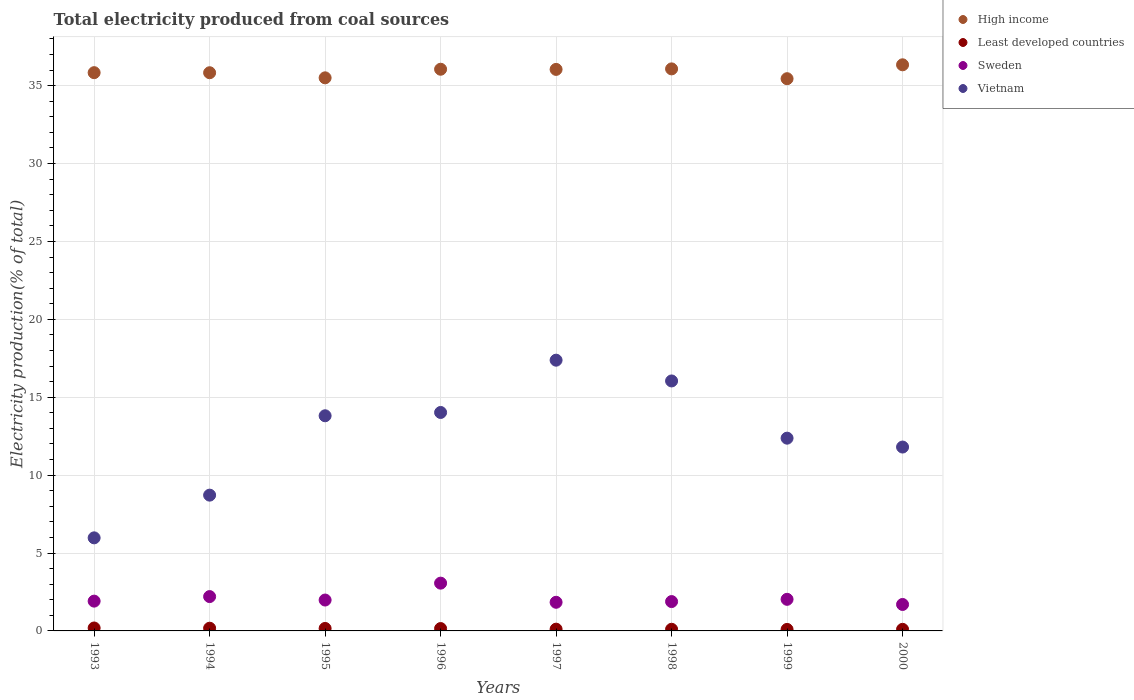What is the total electricity produced in Least developed countries in 1999?
Your answer should be compact. 0.1. Across all years, what is the maximum total electricity produced in Sweden?
Your answer should be very brief. 3.07. Across all years, what is the minimum total electricity produced in Least developed countries?
Offer a terse response. 0.1. In which year was the total electricity produced in Sweden maximum?
Make the answer very short. 1996. What is the total total electricity produced in Sweden in the graph?
Provide a short and direct response. 16.61. What is the difference between the total electricity produced in Sweden in 1995 and that in 1996?
Your answer should be compact. -1.08. What is the difference between the total electricity produced in Sweden in 2000 and the total electricity produced in Least developed countries in 1996?
Keep it short and to the point. 1.55. What is the average total electricity produced in Sweden per year?
Provide a succinct answer. 2.08. In the year 1997, what is the difference between the total electricity produced in Vietnam and total electricity produced in High income?
Make the answer very short. -18.67. What is the ratio of the total electricity produced in Vietnam in 1995 to that in 1999?
Your answer should be very brief. 1.12. Is the total electricity produced in Sweden in 1994 less than that in 1999?
Offer a terse response. No. What is the difference between the highest and the second highest total electricity produced in Vietnam?
Provide a succinct answer. 1.33. What is the difference between the highest and the lowest total electricity produced in Vietnam?
Offer a very short reply. 11.4. In how many years, is the total electricity produced in High income greater than the average total electricity produced in High income taken over all years?
Make the answer very short. 4. Does the total electricity produced in Vietnam monotonically increase over the years?
Provide a short and direct response. No. Is the total electricity produced in High income strictly greater than the total electricity produced in Least developed countries over the years?
Ensure brevity in your answer.  Yes. Is the total electricity produced in Vietnam strictly less than the total electricity produced in High income over the years?
Give a very brief answer. Yes. How many dotlines are there?
Your answer should be very brief. 4. Are the values on the major ticks of Y-axis written in scientific E-notation?
Provide a short and direct response. No. Where does the legend appear in the graph?
Provide a succinct answer. Top right. What is the title of the graph?
Provide a succinct answer. Total electricity produced from coal sources. What is the label or title of the Y-axis?
Offer a terse response. Electricity production(% of total). What is the Electricity production(% of total) in High income in 1993?
Make the answer very short. 35.83. What is the Electricity production(% of total) of Least developed countries in 1993?
Provide a short and direct response. 0.19. What is the Electricity production(% of total) of Sweden in 1993?
Ensure brevity in your answer.  1.91. What is the Electricity production(% of total) in Vietnam in 1993?
Ensure brevity in your answer.  5.97. What is the Electricity production(% of total) in High income in 1994?
Provide a short and direct response. 35.83. What is the Electricity production(% of total) of Least developed countries in 1994?
Ensure brevity in your answer.  0.17. What is the Electricity production(% of total) in Sweden in 1994?
Keep it short and to the point. 2.2. What is the Electricity production(% of total) of Vietnam in 1994?
Provide a succinct answer. 8.72. What is the Electricity production(% of total) of High income in 1995?
Keep it short and to the point. 35.5. What is the Electricity production(% of total) of Least developed countries in 1995?
Keep it short and to the point. 0.16. What is the Electricity production(% of total) of Sweden in 1995?
Provide a short and direct response. 1.98. What is the Electricity production(% of total) of Vietnam in 1995?
Give a very brief answer. 13.81. What is the Electricity production(% of total) of High income in 1996?
Keep it short and to the point. 36.05. What is the Electricity production(% of total) in Least developed countries in 1996?
Keep it short and to the point. 0.15. What is the Electricity production(% of total) in Sweden in 1996?
Ensure brevity in your answer.  3.07. What is the Electricity production(% of total) of Vietnam in 1996?
Offer a very short reply. 14.02. What is the Electricity production(% of total) of High income in 1997?
Make the answer very short. 36.04. What is the Electricity production(% of total) of Least developed countries in 1997?
Offer a terse response. 0.11. What is the Electricity production(% of total) of Sweden in 1997?
Your response must be concise. 1.84. What is the Electricity production(% of total) of Vietnam in 1997?
Keep it short and to the point. 17.38. What is the Electricity production(% of total) of High income in 1998?
Give a very brief answer. 36.08. What is the Electricity production(% of total) of Least developed countries in 1998?
Your response must be concise. 0.11. What is the Electricity production(% of total) in Sweden in 1998?
Offer a very short reply. 1.88. What is the Electricity production(% of total) of Vietnam in 1998?
Ensure brevity in your answer.  16.05. What is the Electricity production(% of total) in High income in 1999?
Give a very brief answer. 35.45. What is the Electricity production(% of total) in Least developed countries in 1999?
Offer a terse response. 0.1. What is the Electricity production(% of total) in Sweden in 1999?
Offer a terse response. 2.03. What is the Electricity production(% of total) of Vietnam in 1999?
Offer a very short reply. 12.37. What is the Electricity production(% of total) in High income in 2000?
Make the answer very short. 36.34. What is the Electricity production(% of total) in Least developed countries in 2000?
Your answer should be compact. 0.1. What is the Electricity production(% of total) of Sweden in 2000?
Offer a terse response. 1.7. What is the Electricity production(% of total) of Vietnam in 2000?
Ensure brevity in your answer.  11.8. Across all years, what is the maximum Electricity production(% of total) of High income?
Provide a short and direct response. 36.34. Across all years, what is the maximum Electricity production(% of total) of Least developed countries?
Keep it short and to the point. 0.19. Across all years, what is the maximum Electricity production(% of total) of Sweden?
Give a very brief answer. 3.07. Across all years, what is the maximum Electricity production(% of total) in Vietnam?
Keep it short and to the point. 17.38. Across all years, what is the minimum Electricity production(% of total) of High income?
Make the answer very short. 35.45. Across all years, what is the minimum Electricity production(% of total) in Least developed countries?
Make the answer very short. 0.1. Across all years, what is the minimum Electricity production(% of total) in Sweden?
Ensure brevity in your answer.  1.7. Across all years, what is the minimum Electricity production(% of total) of Vietnam?
Your answer should be very brief. 5.97. What is the total Electricity production(% of total) in High income in the graph?
Offer a terse response. 287.13. What is the total Electricity production(% of total) of Least developed countries in the graph?
Provide a succinct answer. 1.09. What is the total Electricity production(% of total) of Sweden in the graph?
Offer a very short reply. 16.61. What is the total Electricity production(% of total) of Vietnam in the graph?
Keep it short and to the point. 100.12. What is the difference between the Electricity production(% of total) of High income in 1993 and that in 1994?
Offer a terse response. 0. What is the difference between the Electricity production(% of total) of Least developed countries in 1993 and that in 1994?
Your answer should be compact. 0.01. What is the difference between the Electricity production(% of total) in Sweden in 1993 and that in 1994?
Ensure brevity in your answer.  -0.29. What is the difference between the Electricity production(% of total) of Vietnam in 1993 and that in 1994?
Provide a succinct answer. -2.74. What is the difference between the Electricity production(% of total) in High income in 1993 and that in 1995?
Your answer should be very brief. 0.33. What is the difference between the Electricity production(% of total) in Least developed countries in 1993 and that in 1995?
Your answer should be very brief. 0.03. What is the difference between the Electricity production(% of total) in Sweden in 1993 and that in 1995?
Give a very brief answer. -0.07. What is the difference between the Electricity production(% of total) in Vietnam in 1993 and that in 1995?
Offer a very short reply. -7.84. What is the difference between the Electricity production(% of total) of High income in 1993 and that in 1996?
Keep it short and to the point. -0.22. What is the difference between the Electricity production(% of total) of Least developed countries in 1993 and that in 1996?
Keep it short and to the point. 0.04. What is the difference between the Electricity production(% of total) of Sweden in 1993 and that in 1996?
Offer a very short reply. -1.15. What is the difference between the Electricity production(% of total) of Vietnam in 1993 and that in 1996?
Give a very brief answer. -8.05. What is the difference between the Electricity production(% of total) in High income in 1993 and that in 1997?
Provide a succinct answer. -0.21. What is the difference between the Electricity production(% of total) of Least developed countries in 1993 and that in 1997?
Offer a very short reply. 0.08. What is the difference between the Electricity production(% of total) of Sweden in 1993 and that in 1997?
Keep it short and to the point. 0.07. What is the difference between the Electricity production(% of total) of Vietnam in 1993 and that in 1997?
Your answer should be very brief. -11.4. What is the difference between the Electricity production(% of total) in High income in 1993 and that in 1998?
Your response must be concise. -0.24. What is the difference between the Electricity production(% of total) in Least developed countries in 1993 and that in 1998?
Offer a very short reply. 0.08. What is the difference between the Electricity production(% of total) in Sweden in 1993 and that in 1998?
Ensure brevity in your answer.  0.03. What is the difference between the Electricity production(% of total) in Vietnam in 1993 and that in 1998?
Give a very brief answer. -10.07. What is the difference between the Electricity production(% of total) in High income in 1993 and that in 1999?
Offer a very short reply. 0.39. What is the difference between the Electricity production(% of total) of Least developed countries in 1993 and that in 1999?
Provide a succinct answer. 0.09. What is the difference between the Electricity production(% of total) of Sweden in 1993 and that in 1999?
Offer a terse response. -0.12. What is the difference between the Electricity production(% of total) of Vietnam in 1993 and that in 1999?
Keep it short and to the point. -6.4. What is the difference between the Electricity production(% of total) of High income in 1993 and that in 2000?
Ensure brevity in your answer.  -0.5. What is the difference between the Electricity production(% of total) of Least developed countries in 1993 and that in 2000?
Ensure brevity in your answer.  0.09. What is the difference between the Electricity production(% of total) in Sweden in 1993 and that in 2000?
Offer a terse response. 0.21. What is the difference between the Electricity production(% of total) in Vietnam in 1993 and that in 2000?
Your response must be concise. -5.83. What is the difference between the Electricity production(% of total) of High income in 1994 and that in 1995?
Offer a very short reply. 0.33. What is the difference between the Electricity production(% of total) of Least developed countries in 1994 and that in 1995?
Give a very brief answer. 0.02. What is the difference between the Electricity production(% of total) in Sweden in 1994 and that in 1995?
Your answer should be compact. 0.22. What is the difference between the Electricity production(% of total) in Vietnam in 1994 and that in 1995?
Your response must be concise. -5.09. What is the difference between the Electricity production(% of total) of High income in 1994 and that in 1996?
Offer a terse response. -0.22. What is the difference between the Electricity production(% of total) in Least developed countries in 1994 and that in 1996?
Your response must be concise. 0.02. What is the difference between the Electricity production(% of total) in Sweden in 1994 and that in 1996?
Make the answer very short. -0.86. What is the difference between the Electricity production(% of total) of Vietnam in 1994 and that in 1996?
Provide a succinct answer. -5.31. What is the difference between the Electricity production(% of total) of High income in 1994 and that in 1997?
Ensure brevity in your answer.  -0.21. What is the difference between the Electricity production(% of total) of Least developed countries in 1994 and that in 1997?
Offer a terse response. 0.06. What is the difference between the Electricity production(% of total) of Sweden in 1994 and that in 1997?
Provide a short and direct response. 0.37. What is the difference between the Electricity production(% of total) in Vietnam in 1994 and that in 1997?
Your answer should be very brief. -8.66. What is the difference between the Electricity production(% of total) of High income in 1994 and that in 1998?
Make the answer very short. -0.25. What is the difference between the Electricity production(% of total) in Least developed countries in 1994 and that in 1998?
Give a very brief answer. 0.07. What is the difference between the Electricity production(% of total) in Sweden in 1994 and that in 1998?
Make the answer very short. 0.32. What is the difference between the Electricity production(% of total) in Vietnam in 1994 and that in 1998?
Make the answer very short. -7.33. What is the difference between the Electricity production(% of total) of High income in 1994 and that in 1999?
Your answer should be compact. 0.38. What is the difference between the Electricity production(% of total) of Least developed countries in 1994 and that in 1999?
Ensure brevity in your answer.  0.08. What is the difference between the Electricity production(% of total) of Sweden in 1994 and that in 1999?
Your response must be concise. 0.18. What is the difference between the Electricity production(% of total) of Vietnam in 1994 and that in 1999?
Keep it short and to the point. -3.66. What is the difference between the Electricity production(% of total) in High income in 1994 and that in 2000?
Provide a succinct answer. -0.51. What is the difference between the Electricity production(% of total) of Least developed countries in 1994 and that in 2000?
Keep it short and to the point. 0.07. What is the difference between the Electricity production(% of total) in Sweden in 1994 and that in 2000?
Provide a short and direct response. 0.51. What is the difference between the Electricity production(% of total) in Vietnam in 1994 and that in 2000?
Offer a very short reply. -3.09. What is the difference between the Electricity production(% of total) in High income in 1995 and that in 1996?
Your response must be concise. -0.55. What is the difference between the Electricity production(% of total) in Least developed countries in 1995 and that in 1996?
Ensure brevity in your answer.  0.01. What is the difference between the Electricity production(% of total) of Sweden in 1995 and that in 1996?
Your answer should be compact. -1.08. What is the difference between the Electricity production(% of total) of Vietnam in 1995 and that in 1996?
Your answer should be compact. -0.21. What is the difference between the Electricity production(% of total) in High income in 1995 and that in 1997?
Your answer should be very brief. -0.54. What is the difference between the Electricity production(% of total) in Least developed countries in 1995 and that in 1997?
Offer a terse response. 0.05. What is the difference between the Electricity production(% of total) of Sweden in 1995 and that in 1997?
Your answer should be very brief. 0.14. What is the difference between the Electricity production(% of total) of Vietnam in 1995 and that in 1997?
Give a very brief answer. -3.57. What is the difference between the Electricity production(% of total) in High income in 1995 and that in 1998?
Ensure brevity in your answer.  -0.57. What is the difference between the Electricity production(% of total) in Least developed countries in 1995 and that in 1998?
Provide a succinct answer. 0.05. What is the difference between the Electricity production(% of total) in Sweden in 1995 and that in 1998?
Provide a short and direct response. 0.1. What is the difference between the Electricity production(% of total) in Vietnam in 1995 and that in 1998?
Your answer should be compact. -2.23. What is the difference between the Electricity production(% of total) in High income in 1995 and that in 1999?
Your response must be concise. 0.06. What is the difference between the Electricity production(% of total) in Least developed countries in 1995 and that in 1999?
Offer a terse response. 0.06. What is the difference between the Electricity production(% of total) in Sweden in 1995 and that in 1999?
Provide a short and direct response. -0.05. What is the difference between the Electricity production(% of total) in Vietnam in 1995 and that in 1999?
Your answer should be very brief. 1.44. What is the difference between the Electricity production(% of total) in High income in 1995 and that in 2000?
Your response must be concise. -0.84. What is the difference between the Electricity production(% of total) in Least developed countries in 1995 and that in 2000?
Provide a short and direct response. 0.06. What is the difference between the Electricity production(% of total) of Sweden in 1995 and that in 2000?
Give a very brief answer. 0.28. What is the difference between the Electricity production(% of total) of Vietnam in 1995 and that in 2000?
Provide a succinct answer. 2.01. What is the difference between the Electricity production(% of total) of High income in 1996 and that in 1997?
Provide a short and direct response. 0.01. What is the difference between the Electricity production(% of total) in Least developed countries in 1996 and that in 1997?
Your answer should be compact. 0.04. What is the difference between the Electricity production(% of total) in Sweden in 1996 and that in 1997?
Give a very brief answer. 1.23. What is the difference between the Electricity production(% of total) in Vietnam in 1996 and that in 1997?
Your answer should be very brief. -3.36. What is the difference between the Electricity production(% of total) in High income in 1996 and that in 1998?
Your response must be concise. -0.02. What is the difference between the Electricity production(% of total) of Least developed countries in 1996 and that in 1998?
Offer a very short reply. 0.05. What is the difference between the Electricity production(% of total) in Sweden in 1996 and that in 1998?
Provide a succinct answer. 1.18. What is the difference between the Electricity production(% of total) in Vietnam in 1996 and that in 1998?
Provide a succinct answer. -2.02. What is the difference between the Electricity production(% of total) in High income in 1996 and that in 1999?
Your answer should be very brief. 0.61. What is the difference between the Electricity production(% of total) in Least developed countries in 1996 and that in 1999?
Keep it short and to the point. 0.06. What is the difference between the Electricity production(% of total) in Sweden in 1996 and that in 1999?
Keep it short and to the point. 1.04. What is the difference between the Electricity production(% of total) of Vietnam in 1996 and that in 1999?
Provide a short and direct response. 1.65. What is the difference between the Electricity production(% of total) in High income in 1996 and that in 2000?
Keep it short and to the point. -0.28. What is the difference between the Electricity production(% of total) of Least developed countries in 1996 and that in 2000?
Provide a succinct answer. 0.05. What is the difference between the Electricity production(% of total) of Sweden in 1996 and that in 2000?
Your answer should be compact. 1.37. What is the difference between the Electricity production(% of total) in Vietnam in 1996 and that in 2000?
Provide a short and direct response. 2.22. What is the difference between the Electricity production(% of total) of High income in 1997 and that in 1998?
Give a very brief answer. -0.03. What is the difference between the Electricity production(% of total) in Least developed countries in 1997 and that in 1998?
Make the answer very short. 0.01. What is the difference between the Electricity production(% of total) in Sweden in 1997 and that in 1998?
Provide a short and direct response. -0.05. What is the difference between the Electricity production(% of total) of Vietnam in 1997 and that in 1998?
Provide a succinct answer. 1.33. What is the difference between the Electricity production(% of total) in High income in 1997 and that in 1999?
Give a very brief answer. 0.6. What is the difference between the Electricity production(% of total) in Least developed countries in 1997 and that in 1999?
Keep it short and to the point. 0.02. What is the difference between the Electricity production(% of total) in Sweden in 1997 and that in 1999?
Offer a terse response. -0.19. What is the difference between the Electricity production(% of total) in Vietnam in 1997 and that in 1999?
Provide a short and direct response. 5.01. What is the difference between the Electricity production(% of total) of High income in 1997 and that in 2000?
Your answer should be very brief. -0.29. What is the difference between the Electricity production(% of total) of Least developed countries in 1997 and that in 2000?
Your answer should be compact. 0.01. What is the difference between the Electricity production(% of total) in Sweden in 1997 and that in 2000?
Keep it short and to the point. 0.14. What is the difference between the Electricity production(% of total) of Vietnam in 1997 and that in 2000?
Offer a terse response. 5.58. What is the difference between the Electricity production(% of total) in High income in 1998 and that in 1999?
Ensure brevity in your answer.  0.63. What is the difference between the Electricity production(% of total) in Least developed countries in 1998 and that in 1999?
Offer a terse response. 0.01. What is the difference between the Electricity production(% of total) of Sweden in 1998 and that in 1999?
Offer a terse response. -0.14. What is the difference between the Electricity production(% of total) in Vietnam in 1998 and that in 1999?
Ensure brevity in your answer.  3.67. What is the difference between the Electricity production(% of total) of High income in 1998 and that in 2000?
Keep it short and to the point. -0.26. What is the difference between the Electricity production(% of total) of Least developed countries in 1998 and that in 2000?
Your answer should be compact. 0. What is the difference between the Electricity production(% of total) in Sweden in 1998 and that in 2000?
Give a very brief answer. 0.19. What is the difference between the Electricity production(% of total) in Vietnam in 1998 and that in 2000?
Provide a succinct answer. 4.24. What is the difference between the Electricity production(% of total) of High income in 1999 and that in 2000?
Offer a terse response. -0.89. What is the difference between the Electricity production(% of total) of Least developed countries in 1999 and that in 2000?
Offer a terse response. -0.01. What is the difference between the Electricity production(% of total) of Sweden in 1999 and that in 2000?
Ensure brevity in your answer.  0.33. What is the difference between the Electricity production(% of total) of Vietnam in 1999 and that in 2000?
Offer a terse response. 0.57. What is the difference between the Electricity production(% of total) of High income in 1993 and the Electricity production(% of total) of Least developed countries in 1994?
Provide a succinct answer. 35.66. What is the difference between the Electricity production(% of total) in High income in 1993 and the Electricity production(% of total) in Sweden in 1994?
Your response must be concise. 33.63. What is the difference between the Electricity production(% of total) in High income in 1993 and the Electricity production(% of total) in Vietnam in 1994?
Ensure brevity in your answer.  27.12. What is the difference between the Electricity production(% of total) in Least developed countries in 1993 and the Electricity production(% of total) in Sweden in 1994?
Keep it short and to the point. -2.02. What is the difference between the Electricity production(% of total) of Least developed countries in 1993 and the Electricity production(% of total) of Vietnam in 1994?
Make the answer very short. -8.53. What is the difference between the Electricity production(% of total) of Sweden in 1993 and the Electricity production(% of total) of Vietnam in 1994?
Provide a succinct answer. -6.8. What is the difference between the Electricity production(% of total) of High income in 1993 and the Electricity production(% of total) of Least developed countries in 1995?
Make the answer very short. 35.68. What is the difference between the Electricity production(% of total) in High income in 1993 and the Electricity production(% of total) in Sweden in 1995?
Your answer should be very brief. 33.85. What is the difference between the Electricity production(% of total) in High income in 1993 and the Electricity production(% of total) in Vietnam in 1995?
Give a very brief answer. 22.02. What is the difference between the Electricity production(% of total) of Least developed countries in 1993 and the Electricity production(% of total) of Sweden in 1995?
Provide a short and direct response. -1.79. What is the difference between the Electricity production(% of total) of Least developed countries in 1993 and the Electricity production(% of total) of Vietnam in 1995?
Offer a very short reply. -13.62. What is the difference between the Electricity production(% of total) of Sweden in 1993 and the Electricity production(% of total) of Vietnam in 1995?
Your answer should be very brief. -11.9. What is the difference between the Electricity production(% of total) in High income in 1993 and the Electricity production(% of total) in Least developed countries in 1996?
Your answer should be very brief. 35.68. What is the difference between the Electricity production(% of total) in High income in 1993 and the Electricity production(% of total) in Sweden in 1996?
Your answer should be compact. 32.77. What is the difference between the Electricity production(% of total) in High income in 1993 and the Electricity production(% of total) in Vietnam in 1996?
Your response must be concise. 21.81. What is the difference between the Electricity production(% of total) of Least developed countries in 1993 and the Electricity production(% of total) of Sweden in 1996?
Your answer should be very brief. -2.88. What is the difference between the Electricity production(% of total) in Least developed countries in 1993 and the Electricity production(% of total) in Vietnam in 1996?
Provide a short and direct response. -13.83. What is the difference between the Electricity production(% of total) in Sweden in 1993 and the Electricity production(% of total) in Vietnam in 1996?
Keep it short and to the point. -12.11. What is the difference between the Electricity production(% of total) in High income in 1993 and the Electricity production(% of total) in Least developed countries in 1997?
Provide a succinct answer. 35.72. What is the difference between the Electricity production(% of total) in High income in 1993 and the Electricity production(% of total) in Sweden in 1997?
Your answer should be very brief. 34. What is the difference between the Electricity production(% of total) of High income in 1993 and the Electricity production(% of total) of Vietnam in 1997?
Your response must be concise. 18.46. What is the difference between the Electricity production(% of total) in Least developed countries in 1993 and the Electricity production(% of total) in Sweden in 1997?
Your answer should be compact. -1.65. What is the difference between the Electricity production(% of total) in Least developed countries in 1993 and the Electricity production(% of total) in Vietnam in 1997?
Provide a succinct answer. -17.19. What is the difference between the Electricity production(% of total) of Sweden in 1993 and the Electricity production(% of total) of Vietnam in 1997?
Make the answer very short. -15.47. What is the difference between the Electricity production(% of total) of High income in 1993 and the Electricity production(% of total) of Least developed countries in 1998?
Provide a succinct answer. 35.73. What is the difference between the Electricity production(% of total) in High income in 1993 and the Electricity production(% of total) in Sweden in 1998?
Keep it short and to the point. 33.95. What is the difference between the Electricity production(% of total) in High income in 1993 and the Electricity production(% of total) in Vietnam in 1998?
Offer a terse response. 19.79. What is the difference between the Electricity production(% of total) of Least developed countries in 1993 and the Electricity production(% of total) of Sweden in 1998?
Offer a very short reply. -1.7. What is the difference between the Electricity production(% of total) of Least developed countries in 1993 and the Electricity production(% of total) of Vietnam in 1998?
Your answer should be very brief. -15.86. What is the difference between the Electricity production(% of total) in Sweden in 1993 and the Electricity production(% of total) in Vietnam in 1998?
Provide a short and direct response. -14.13. What is the difference between the Electricity production(% of total) in High income in 1993 and the Electricity production(% of total) in Least developed countries in 1999?
Your response must be concise. 35.74. What is the difference between the Electricity production(% of total) in High income in 1993 and the Electricity production(% of total) in Sweden in 1999?
Offer a very short reply. 33.81. What is the difference between the Electricity production(% of total) in High income in 1993 and the Electricity production(% of total) in Vietnam in 1999?
Keep it short and to the point. 23.46. What is the difference between the Electricity production(% of total) in Least developed countries in 1993 and the Electricity production(% of total) in Sweden in 1999?
Ensure brevity in your answer.  -1.84. What is the difference between the Electricity production(% of total) of Least developed countries in 1993 and the Electricity production(% of total) of Vietnam in 1999?
Your answer should be very brief. -12.18. What is the difference between the Electricity production(% of total) of Sweden in 1993 and the Electricity production(% of total) of Vietnam in 1999?
Ensure brevity in your answer.  -10.46. What is the difference between the Electricity production(% of total) of High income in 1993 and the Electricity production(% of total) of Least developed countries in 2000?
Ensure brevity in your answer.  35.73. What is the difference between the Electricity production(% of total) in High income in 1993 and the Electricity production(% of total) in Sweden in 2000?
Your response must be concise. 34.14. What is the difference between the Electricity production(% of total) in High income in 1993 and the Electricity production(% of total) in Vietnam in 2000?
Provide a succinct answer. 24.03. What is the difference between the Electricity production(% of total) of Least developed countries in 1993 and the Electricity production(% of total) of Sweden in 2000?
Offer a terse response. -1.51. What is the difference between the Electricity production(% of total) of Least developed countries in 1993 and the Electricity production(% of total) of Vietnam in 2000?
Ensure brevity in your answer.  -11.61. What is the difference between the Electricity production(% of total) of Sweden in 1993 and the Electricity production(% of total) of Vietnam in 2000?
Keep it short and to the point. -9.89. What is the difference between the Electricity production(% of total) of High income in 1994 and the Electricity production(% of total) of Least developed countries in 1995?
Ensure brevity in your answer.  35.67. What is the difference between the Electricity production(% of total) in High income in 1994 and the Electricity production(% of total) in Sweden in 1995?
Offer a very short reply. 33.85. What is the difference between the Electricity production(% of total) in High income in 1994 and the Electricity production(% of total) in Vietnam in 1995?
Keep it short and to the point. 22.02. What is the difference between the Electricity production(% of total) of Least developed countries in 1994 and the Electricity production(% of total) of Sweden in 1995?
Your response must be concise. -1.81. What is the difference between the Electricity production(% of total) of Least developed countries in 1994 and the Electricity production(% of total) of Vietnam in 1995?
Provide a short and direct response. -13.64. What is the difference between the Electricity production(% of total) in Sweden in 1994 and the Electricity production(% of total) in Vietnam in 1995?
Your answer should be compact. -11.61. What is the difference between the Electricity production(% of total) in High income in 1994 and the Electricity production(% of total) in Least developed countries in 1996?
Ensure brevity in your answer.  35.68. What is the difference between the Electricity production(% of total) of High income in 1994 and the Electricity production(% of total) of Sweden in 1996?
Offer a terse response. 32.76. What is the difference between the Electricity production(% of total) of High income in 1994 and the Electricity production(% of total) of Vietnam in 1996?
Offer a very short reply. 21.81. What is the difference between the Electricity production(% of total) of Least developed countries in 1994 and the Electricity production(% of total) of Sweden in 1996?
Your answer should be very brief. -2.89. What is the difference between the Electricity production(% of total) of Least developed countries in 1994 and the Electricity production(% of total) of Vietnam in 1996?
Ensure brevity in your answer.  -13.85. What is the difference between the Electricity production(% of total) of Sweden in 1994 and the Electricity production(% of total) of Vietnam in 1996?
Keep it short and to the point. -11.82. What is the difference between the Electricity production(% of total) in High income in 1994 and the Electricity production(% of total) in Least developed countries in 1997?
Your response must be concise. 35.72. What is the difference between the Electricity production(% of total) of High income in 1994 and the Electricity production(% of total) of Sweden in 1997?
Give a very brief answer. 33.99. What is the difference between the Electricity production(% of total) in High income in 1994 and the Electricity production(% of total) in Vietnam in 1997?
Your response must be concise. 18.45. What is the difference between the Electricity production(% of total) of Least developed countries in 1994 and the Electricity production(% of total) of Sweden in 1997?
Give a very brief answer. -1.66. What is the difference between the Electricity production(% of total) in Least developed countries in 1994 and the Electricity production(% of total) in Vietnam in 1997?
Offer a very short reply. -17.2. What is the difference between the Electricity production(% of total) in Sweden in 1994 and the Electricity production(% of total) in Vietnam in 1997?
Your answer should be compact. -15.18. What is the difference between the Electricity production(% of total) in High income in 1994 and the Electricity production(% of total) in Least developed countries in 1998?
Provide a short and direct response. 35.72. What is the difference between the Electricity production(% of total) in High income in 1994 and the Electricity production(% of total) in Sweden in 1998?
Offer a very short reply. 33.95. What is the difference between the Electricity production(% of total) in High income in 1994 and the Electricity production(% of total) in Vietnam in 1998?
Ensure brevity in your answer.  19.78. What is the difference between the Electricity production(% of total) of Least developed countries in 1994 and the Electricity production(% of total) of Sweden in 1998?
Make the answer very short. -1.71. What is the difference between the Electricity production(% of total) of Least developed countries in 1994 and the Electricity production(% of total) of Vietnam in 1998?
Offer a terse response. -15.87. What is the difference between the Electricity production(% of total) in Sweden in 1994 and the Electricity production(% of total) in Vietnam in 1998?
Make the answer very short. -13.84. What is the difference between the Electricity production(% of total) of High income in 1994 and the Electricity production(% of total) of Least developed countries in 1999?
Provide a succinct answer. 35.73. What is the difference between the Electricity production(% of total) of High income in 1994 and the Electricity production(% of total) of Sweden in 1999?
Your answer should be very brief. 33.8. What is the difference between the Electricity production(% of total) in High income in 1994 and the Electricity production(% of total) in Vietnam in 1999?
Provide a short and direct response. 23.46. What is the difference between the Electricity production(% of total) in Least developed countries in 1994 and the Electricity production(% of total) in Sweden in 1999?
Make the answer very short. -1.85. What is the difference between the Electricity production(% of total) in Least developed countries in 1994 and the Electricity production(% of total) in Vietnam in 1999?
Keep it short and to the point. -12.2. What is the difference between the Electricity production(% of total) of Sweden in 1994 and the Electricity production(% of total) of Vietnam in 1999?
Provide a short and direct response. -10.17. What is the difference between the Electricity production(% of total) of High income in 1994 and the Electricity production(% of total) of Least developed countries in 2000?
Offer a terse response. 35.73. What is the difference between the Electricity production(% of total) of High income in 1994 and the Electricity production(% of total) of Sweden in 2000?
Provide a succinct answer. 34.13. What is the difference between the Electricity production(% of total) of High income in 1994 and the Electricity production(% of total) of Vietnam in 2000?
Your answer should be compact. 24.03. What is the difference between the Electricity production(% of total) in Least developed countries in 1994 and the Electricity production(% of total) in Sweden in 2000?
Offer a terse response. -1.52. What is the difference between the Electricity production(% of total) of Least developed countries in 1994 and the Electricity production(% of total) of Vietnam in 2000?
Provide a succinct answer. -11.63. What is the difference between the Electricity production(% of total) of Sweden in 1994 and the Electricity production(% of total) of Vietnam in 2000?
Make the answer very short. -9.6. What is the difference between the Electricity production(% of total) of High income in 1995 and the Electricity production(% of total) of Least developed countries in 1996?
Your answer should be very brief. 35.35. What is the difference between the Electricity production(% of total) of High income in 1995 and the Electricity production(% of total) of Sweden in 1996?
Your response must be concise. 32.44. What is the difference between the Electricity production(% of total) in High income in 1995 and the Electricity production(% of total) in Vietnam in 1996?
Your answer should be very brief. 21.48. What is the difference between the Electricity production(% of total) of Least developed countries in 1995 and the Electricity production(% of total) of Sweden in 1996?
Provide a succinct answer. -2.91. What is the difference between the Electricity production(% of total) in Least developed countries in 1995 and the Electricity production(% of total) in Vietnam in 1996?
Your answer should be very brief. -13.86. What is the difference between the Electricity production(% of total) of Sweden in 1995 and the Electricity production(% of total) of Vietnam in 1996?
Make the answer very short. -12.04. What is the difference between the Electricity production(% of total) of High income in 1995 and the Electricity production(% of total) of Least developed countries in 1997?
Ensure brevity in your answer.  35.39. What is the difference between the Electricity production(% of total) of High income in 1995 and the Electricity production(% of total) of Sweden in 1997?
Offer a very short reply. 33.66. What is the difference between the Electricity production(% of total) of High income in 1995 and the Electricity production(% of total) of Vietnam in 1997?
Provide a succinct answer. 18.12. What is the difference between the Electricity production(% of total) of Least developed countries in 1995 and the Electricity production(% of total) of Sweden in 1997?
Offer a very short reply. -1.68. What is the difference between the Electricity production(% of total) of Least developed countries in 1995 and the Electricity production(% of total) of Vietnam in 1997?
Ensure brevity in your answer.  -17.22. What is the difference between the Electricity production(% of total) in Sweden in 1995 and the Electricity production(% of total) in Vietnam in 1997?
Ensure brevity in your answer.  -15.4. What is the difference between the Electricity production(% of total) of High income in 1995 and the Electricity production(% of total) of Least developed countries in 1998?
Offer a terse response. 35.4. What is the difference between the Electricity production(% of total) in High income in 1995 and the Electricity production(% of total) in Sweden in 1998?
Your response must be concise. 33.62. What is the difference between the Electricity production(% of total) in High income in 1995 and the Electricity production(% of total) in Vietnam in 1998?
Your response must be concise. 19.46. What is the difference between the Electricity production(% of total) in Least developed countries in 1995 and the Electricity production(% of total) in Sweden in 1998?
Provide a succinct answer. -1.72. What is the difference between the Electricity production(% of total) of Least developed countries in 1995 and the Electricity production(% of total) of Vietnam in 1998?
Your answer should be compact. -15.89. What is the difference between the Electricity production(% of total) in Sweden in 1995 and the Electricity production(% of total) in Vietnam in 1998?
Provide a succinct answer. -14.06. What is the difference between the Electricity production(% of total) in High income in 1995 and the Electricity production(% of total) in Least developed countries in 1999?
Provide a succinct answer. 35.41. What is the difference between the Electricity production(% of total) in High income in 1995 and the Electricity production(% of total) in Sweden in 1999?
Offer a very short reply. 33.47. What is the difference between the Electricity production(% of total) of High income in 1995 and the Electricity production(% of total) of Vietnam in 1999?
Ensure brevity in your answer.  23.13. What is the difference between the Electricity production(% of total) of Least developed countries in 1995 and the Electricity production(% of total) of Sweden in 1999?
Provide a succinct answer. -1.87. What is the difference between the Electricity production(% of total) in Least developed countries in 1995 and the Electricity production(% of total) in Vietnam in 1999?
Ensure brevity in your answer.  -12.21. What is the difference between the Electricity production(% of total) of Sweden in 1995 and the Electricity production(% of total) of Vietnam in 1999?
Provide a short and direct response. -10.39. What is the difference between the Electricity production(% of total) of High income in 1995 and the Electricity production(% of total) of Least developed countries in 2000?
Make the answer very short. 35.4. What is the difference between the Electricity production(% of total) of High income in 1995 and the Electricity production(% of total) of Sweden in 2000?
Provide a short and direct response. 33.81. What is the difference between the Electricity production(% of total) in High income in 1995 and the Electricity production(% of total) in Vietnam in 2000?
Keep it short and to the point. 23.7. What is the difference between the Electricity production(% of total) in Least developed countries in 1995 and the Electricity production(% of total) in Sweden in 2000?
Ensure brevity in your answer.  -1.54. What is the difference between the Electricity production(% of total) in Least developed countries in 1995 and the Electricity production(% of total) in Vietnam in 2000?
Provide a short and direct response. -11.64. What is the difference between the Electricity production(% of total) in Sweden in 1995 and the Electricity production(% of total) in Vietnam in 2000?
Make the answer very short. -9.82. What is the difference between the Electricity production(% of total) of High income in 1996 and the Electricity production(% of total) of Least developed countries in 1997?
Provide a short and direct response. 35.94. What is the difference between the Electricity production(% of total) of High income in 1996 and the Electricity production(% of total) of Sweden in 1997?
Provide a short and direct response. 34.22. What is the difference between the Electricity production(% of total) of High income in 1996 and the Electricity production(% of total) of Vietnam in 1997?
Make the answer very short. 18.68. What is the difference between the Electricity production(% of total) in Least developed countries in 1996 and the Electricity production(% of total) in Sweden in 1997?
Provide a short and direct response. -1.69. What is the difference between the Electricity production(% of total) in Least developed countries in 1996 and the Electricity production(% of total) in Vietnam in 1997?
Your answer should be compact. -17.23. What is the difference between the Electricity production(% of total) in Sweden in 1996 and the Electricity production(% of total) in Vietnam in 1997?
Ensure brevity in your answer.  -14.31. What is the difference between the Electricity production(% of total) in High income in 1996 and the Electricity production(% of total) in Least developed countries in 1998?
Provide a short and direct response. 35.95. What is the difference between the Electricity production(% of total) in High income in 1996 and the Electricity production(% of total) in Sweden in 1998?
Provide a succinct answer. 34.17. What is the difference between the Electricity production(% of total) in High income in 1996 and the Electricity production(% of total) in Vietnam in 1998?
Give a very brief answer. 20.01. What is the difference between the Electricity production(% of total) of Least developed countries in 1996 and the Electricity production(% of total) of Sweden in 1998?
Keep it short and to the point. -1.73. What is the difference between the Electricity production(% of total) in Least developed countries in 1996 and the Electricity production(% of total) in Vietnam in 1998?
Provide a short and direct response. -15.89. What is the difference between the Electricity production(% of total) in Sweden in 1996 and the Electricity production(% of total) in Vietnam in 1998?
Offer a terse response. -12.98. What is the difference between the Electricity production(% of total) of High income in 1996 and the Electricity production(% of total) of Least developed countries in 1999?
Your answer should be very brief. 35.96. What is the difference between the Electricity production(% of total) of High income in 1996 and the Electricity production(% of total) of Sweden in 1999?
Provide a succinct answer. 34.03. What is the difference between the Electricity production(% of total) in High income in 1996 and the Electricity production(% of total) in Vietnam in 1999?
Offer a very short reply. 23.68. What is the difference between the Electricity production(% of total) in Least developed countries in 1996 and the Electricity production(% of total) in Sweden in 1999?
Provide a succinct answer. -1.88. What is the difference between the Electricity production(% of total) in Least developed countries in 1996 and the Electricity production(% of total) in Vietnam in 1999?
Your answer should be very brief. -12.22. What is the difference between the Electricity production(% of total) of Sweden in 1996 and the Electricity production(% of total) of Vietnam in 1999?
Give a very brief answer. -9.31. What is the difference between the Electricity production(% of total) in High income in 1996 and the Electricity production(% of total) in Least developed countries in 2000?
Offer a very short reply. 35.95. What is the difference between the Electricity production(% of total) in High income in 1996 and the Electricity production(% of total) in Sweden in 2000?
Ensure brevity in your answer.  34.36. What is the difference between the Electricity production(% of total) in High income in 1996 and the Electricity production(% of total) in Vietnam in 2000?
Make the answer very short. 24.25. What is the difference between the Electricity production(% of total) in Least developed countries in 1996 and the Electricity production(% of total) in Sweden in 2000?
Provide a short and direct response. -1.55. What is the difference between the Electricity production(% of total) of Least developed countries in 1996 and the Electricity production(% of total) of Vietnam in 2000?
Ensure brevity in your answer.  -11.65. What is the difference between the Electricity production(% of total) in Sweden in 1996 and the Electricity production(% of total) in Vietnam in 2000?
Make the answer very short. -8.74. What is the difference between the Electricity production(% of total) in High income in 1997 and the Electricity production(% of total) in Least developed countries in 1998?
Offer a very short reply. 35.94. What is the difference between the Electricity production(% of total) in High income in 1997 and the Electricity production(% of total) in Sweden in 1998?
Provide a succinct answer. 34.16. What is the difference between the Electricity production(% of total) in High income in 1997 and the Electricity production(% of total) in Vietnam in 1998?
Keep it short and to the point. 20. What is the difference between the Electricity production(% of total) of Least developed countries in 1997 and the Electricity production(% of total) of Sweden in 1998?
Your answer should be compact. -1.77. What is the difference between the Electricity production(% of total) of Least developed countries in 1997 and the Electricity production(% of total) of Vietnam in 1998?
Offer a very short reply. -15.93. What is the difference between the Electricity production(% of total) of Sweden in 1997 and the Electricity production(% of total) of Vietnam in 1998?
Make the answer very short. -14.21. What is the difference between the Electricity production(% of total) in High income in 1997 and the Electricity production(% of total) in Least developed countries in 1999?
Offer a terse response. 35.95. What is the difference between the Electricity production(% of total) of High income in 1997 and the Electricity production(% of total) of Sweden in 1999?
Offer a terse response. 34.02. What is the difference between the Electricity production(% of total) of High income in 1997 and the Electricity production(% of total) of Vietnam in 1999?
Provide a succinct answer. 23.67. What is the difference between the Electricity production(% of total) in Least developed countries in 1997 and the Electricity production(% of total) in Sweden in 1999?
Provide a short and direct response. -1.92. What is the difference between the Electricity production(% of total) of Least developed countries in 1997 and the Electricity production(% of total) of Vietnam in 1999?
Give a very brief answer. -12.26. What is the difference between the Electricity production(% of total) of Sweden in 1997 and the Electricity production(% of total) of Vietnam in 1999?
Give a very brief answer. -10.53. What is the difference between the Electricity production(% of total) of High income in 1997 and the Electricity production(% of total) of Least developed countries in 2000?
Your response must be concise. 35.94. What is the difference between the Electricity production(% of total) of High income in 1997 and the Electricity production(% of total) of Sweden in 2000?
Offer a terse response. 34.35. What is the difference between the Electricity production(% of total) in High income in 1997 and the Electricity production(% of total) in Vietnam in 2000?
Your answer should be compact. 24.24. What is the difference between the Electricity production(% of total) in Least developed countries in 1997 and the Electricity production(% of total) in Sweden in 2000?
Provide a short and direct response. -1.58. What is the difference between the Electricity production(% of total) of Least developed countries in 1997 and the Electricity production(% of total) of Vietnam in 2000?
Your answer should be compact. -11.69. What is the difference between the Electricity production(% of total) in Sweden in 1997 and the Electricity production(% of total) in Vietnam in 2000?
Your response must be concise. -9.96. What is the difference between the Electricity production(% of total) of High income in 1998 and the Electricity production(% of total) of Least developed countries in 1999?
Your response must be concise. 35.98. What is the difference between the Electricity production(% of total) of High income in 1998 and the Electricity production(% of total) of Sweden in 1999?
Offer a very short reply. 34.05. What is the difference between the Electricity production(% of total) of High income in 1998 and the Electricity production(% of total) of Vietnam in 1999?
Your answer should be very brief. 23.7. What is the difference between the Electricity production(% of total) of Least developed countries in 1998 and the Electricity production(% of total) of Sweden in 1999?
Your answer should be compact. -1.92. What is the difference between the Electricity production(% of total) of Least developed countries in 1998 and the Electricity production(% of total) of Vietnam in 1999?
Make the answer very short. -12.27. What is the difference between the Electricity production(% of total) in Sweden in 1998 and the Electricity production(% of total) in Vietnam in 1999?
Provide a short and direct response. -10.49. What is the difference between the Electricity production(% of total) in High income in 1998 and the Electricity production(% of total) in Least developed countries in 2000?
Provide a succinct answer. 35.98. What is the difference between the Electricity production(% of total) of High income in 1998 and the Electricity production(% of total) of Sweden in 2000?
Your response must be concise. 34.38. What is the difference between the Electricity production(% of total) in High income in 1998 and the Electricity production(% of total) in Vietnam in 2000?
Offer a very short reply. 24.27. What is the difference between the Electricity production(% of total) in Least developed countries in 1998 and the Electricity production(% of total) in Sweden in 2000?
Your response must be concise. -1.59. What is the difference between the Electricity production(% of total) in Least developed countries in 1998 and the Electricity production(% of total) in Vietnam in 2000?
Your answer should be compact. -11.7. What is the difference between the Electricity production(% of total) of Sweden in 1998 and the Electricity production(% of total) of Vietnam in 2000?
Offer a terse response. -9.92. What is the difference between the Electricity production(% of total) of High income in 1999 and the Electricity production(% of total) of Least developed countries in 2000?
Provide a succinct answer. 35.35. What is the difference between the Electricity production(% of total) in High income in 1999 and the Electricity production(% of total) in Sweden in 2000?
Provide a short and direct response. 33.75. What is the difference between the Electricity production(% of total) of High income in 1999 and the Electricity production(% of total) of Vietnam in 2000?
Ensure brevity in your answer.  23.64. What is the difference between the Electricity production(% of total) of Least developed countries in 1999 and the Electricity production(% of total) of Sweden in 2000?
Your response must be concise. -1.6. What is the difference between the Electricity production(% of total) of Least developed countries in 1999 and the Electricity production(% of total) of Vietnam in 2000?
Ensure brevity in your answer.  -11.71. What is the difference between the Electricity production(% of total) in Sweden in 1999 and the Electricity production(% of total) in Vietnam in 2000?
Give a very brief answer. -9.77. What is the average Electricity production(% of total) of High income per year?
Offer a very short reply. 35.89. What is the average Electricity production(% of total) in Least developed countries per year?
Your answer should be compact. 0.14. What is the average Electricity production(% of total) in Sweden per year?
Ensure brevity in your answer.  2.08. What is the average Electricity production(% of total) of Vietnam per year?
Make the answer very short. 12.52. In the year 1993, what is the difference between the Electricity production(% of total) of High income and Electricity production(% of total) of Least developed countries?
Your answer should be very brief. 35.65. In the year 1993, what is the difference between the Electricity production(% of total) in High income and Electricity production(% of total) in Sweden?
Your response must be concise. 33.92. In the year 1993, what is the difference between the Electricity production(% of total) of High income and Electricity production(% of total) of Vietnam?
Your answer should be compact. 29.86. In the year 1993, what is the difference between the Electricity production(% of total) of Least developed countries and Electricity production(% of total) of Sweden?
Offer a very short reply. -1.72. In the year 1993, what is the difference between the Electricity production(% of total) in Least developed countries and Electricity production(% of total) in Vietnam?
Offer a very short reply. -5.79. In the year 1993, what is the difference between the Electricity production(% of total) in Sweden and Electricity production(% of total) in Vietnam?
Make the answer very short. -4.06. In the year 1994, what is the difference between the Electricity production(% of total) in High income and Electricity production(% of total) in Least developed countries?
Provide a short and direct response. 35.66. In the year 1994, what is the difference between the Electricity production(% of total) of High income and Electricity production(% of total) of Sweden?
Provide a succinct answer. 33.63. In the year 1994, what is the difference between the Electricity production(% of total) in High income and Electricity production(% of total) in Vietnam?
Your response must be concise. 27.11. In the year 1994, what is the difference between the Electricity production(% of total) of Least developed countries and Electricity production(% of total) of Sweden?
Provide a succinct answer. -2.03. In the year 1994, what is the difference between the Electricity production(% of total) of Least developed countries and Electricity production(% of total) of Vietnam?
Make the answer very short. -8.54. In the year 1994, what is the difference between the Electricity production(% of total) of Sweden and Electricity production(% of total) of Vietnam?
Offer a terse response. -6.51. In the year 1995, what is the difference between the Electricity production(% of total) of High income and Electricity production(% of total) of Least developed countries?
Provide a short and direct response. 35.34. In the year 1995, what is the difference between the Electricity production(% of total) in High income and Electricity production(% of total) in Sweden?
Provide a succinct answer. 33.52. In the year 1995, what is the difference between the Electricity production(% of total) of High income and Electricity production(% of total) of Vietnam?
Provide a short and direct response. 21.69. In the year 1995, what is the difference between the Electricity production(% of total) in Least developed countries and Electricity production(% of total) in Sweden?
Keep it short and to the point. -1.82. In the year 1995, what is the difference between the Electricity production(% of total) in Least developed countries and Electricity production(% of total) in Vietnam?
Provide a succinct answer. -13.65. In the year 1995, what is the difference between the Electricity production(% of total) in Sweden and Electricity production(% of total) in Vietnam?
Your answer should be compact. -11.83. In the year 1996, what is the difference between the Electricity production(% of total) of High income and Electricity production(% of total) of Least developed countries?
Ensure brevity in your answer.  35.9. In the year 1996, what is the difference between the Electricity production(% of total) in High income and Electricity production(% of total) in Sweden?
Offer a terse response. 32.99. In the year 1996, what is the difference between the Electricity production(% of total) in High income and Electricity production(% of total) in Vietnam?
Your response must be concise. 22.03. In the year 1996, what is the difference between the Electricity production(% of total) of Least developed countries and Electricity production(% of total) of Sweden?
Your answer should be very brief. -2.91. In the year 1996, what is the difference between the Electricity production(% of total) of Least developed countries and Electricity production(% of total) of Vietnam?
Your response must be concise. -13.87. In the year 1996, what is the difference between the Electricity production(% of total) of Sweden and Electricity production(% of total) of Vietnam?
Your answer should be very brief. -10.96. In the year 1997, what is the difference between the Electricity production(% of total) of High income and Electricity production(% of total) of Least developed countries?
Give a very brief answer. 35.93. In the year 1997, what is the difference between the Electricity production(% of total) of High income and Electricity production(% of total) of Sweden?
Provide a succinct answer. 34.21. In the year 1997, what is the difference between the Electricity production(% of total) of High income and Electricity production(% of total) of Vietnam?
Provide a short and direct response. 18.67. In the year 1997, what is the difference between the Electricity production(% of total) of Least developed countries and Electricity production(% of total) of Sweden?
Give a very brief answer. -1.73. In the year 1997, what is the difference between the Electricity production(% of total) of Least developed countries and Electricity production(% of total) of Vietnam?
Your answer should be compact. -17.27. In the year 1997, what is the difference between the Electricity production(% of total) of Sweden and Electricity production(% of total) of Vietnam?
Offer a terse response. -15.54. In the year 1998, what is the difference between the Electricity production(% of total) in High income and Electricity production(% of total) in Least developed countries?
Offer a terse response. 35.97. In the year 1998, what is the difference between the Electricity production(% of total) of High income and Electricity production(% of total) of Sweden?
Provide a succinct answer. 34.19. In the year 1998, what is the difference between the Electricity production(% of total) in High income and Electricity production(% of total) in Vietnam?
Offer a very short reply. 20.03. In the year 1998, what is the difference between the Electricity production(% of total) of Least developed countries and Electricity production(% of total) of Sweden?
Offer a very short reply. -1.78. In the year 1998, what is the difference between the Electricity production(% of total) in Least developed countries and Electricity production(% of total) in Vietnam?
Your answer should be compact. -15.94. In the year 1998, what is the difference between the Electricity production(% of total) in Sweden and Electricity production(% of total) in Vietnam?
Provide a succinct answer. -14.16. In the year 1999, what is the difference between the Electricity production(% of total) in High income and Electricity production(% of total) in Least developed countries?
Provide a succinct answer. 35.35. In the year 1999, what is the difference between the Electricity production(% of total) in High income and Electricity production(% of total) in Sweden?
Offer a terse response. 33.42. In the year 1999, what is the difference between the Electricity production(% of total) in High income and Electricity production(% of total) in Vietnam?
Keep it short and to the point. 23.07. In the year 1999, what is the difference between the Electricity production(% of total) in Least developed countries and Electricity production(% of total) in Sweden?
Make the answer very short. -1.93. In the year 1999, what is the difference between the Electricity production(% of total) in Least developed countries and Electricity production(% of total) in Vietnam?
Offer a terse response. -12.28. In the year 1999, what is the difference between the Electricity production(% of total) of Sweden and Electricity production(% of total) of Vietnam?
Keep it short and to the point. -10.34. In the year 2000, what is the difference between the Electricity production(% of total) of High income and Electricity production(% of total) of Least developed countries?
Keep it short and to the point. 36.24. In the year 2000, what is the difference between the Electricity production(% of total) in High income and Electricity production(% of total) in Sweden?
Give a very brief answer. 34.64. In the year 2000, what is the difference between the Electricity production(% of total) of High income and Electricity production(% of total) of Vietnam?
Give a very brief answer. 24.54. In the year 2000, what is the difference between the Electricity production(% of total) in Least developed countries and Electricity production(% of total) in Sweden?
Make the answer very short. -1.6. In the year 2000, what is the difference between the Electricity production(% of total) in Least developed countries and Electricity production(% of total) in Vietnam?
Ensure brevity in your answer.  -11.7. In the year 2000, what is the difference between the Electricity production(% of total) of Sweden and Electricity production(% of total) of Vietnam?
Your answer should be very brief. -10.11. What is the ratio of the Electricity production(% of total) of Least developed countries in 1993 to that in 1994?
Offer a terse response. 1.08. What is the ratio of the Electricity production(% of total) in Sweden in 1993 to that in 1994?
Your answer should be very brief. 0.87. What is the ratio of the Electricity production(% of total) of Vietnam in 1993 to that in 1994?
Give a very brief answer. 0.69. What is the ratio of the Electricity production(% of total) in High income in 1993 to that in 1995?
Provide a short and direct response. 1.01. What is the ratio of the Electricity production(% of total) of Least developed countries in 1993 to that in 1995?
Ensure brevity in your answer.  1.18. What is the ratio of the Electricity production(% of total) in Sweden in 1993 to that in 1995?
Offer a very short reply. 0.96. What is the ratio of the Electricity production(% of total) in Vietnam in 1993 to that in 1995?
Ensure brevity in your answer.  0.43. What is the ratio of the Electricity production(% of total) in High income in 1993 to that in 1996?
Your answer should be very brief. 0.99. What is the ratio of the Electricity production(% of total) of Least developed countries in 1993 to that in 1996?
Ensure brevity in your answer.  1.24. What is the ratio of the Electricity production(% of total) of Sweden in 1993 to that in 1996?
Offer a very short reply. 0.62. What is the ratio of the Electricity production(% of total) of Vietnam in 1993 to that in 1996?
Ensure brevity in your answer.  0.43. What is the ratio of the Electricity production(% of total) of Least developed countries in 1993 to that in 1997?
Offer a very short reply. 1.67. What is the ratio of the Electricity production(% of total) in Sweden in 1993 to that in 1997?
Keep it short and to the point. 1.04. What is the ratio of the Electricity production(% of total) of Vietnam in 1993 to that in 1997?
Offer a very short reply. 0.34. What is the ratio of the Electricity production(% of total) in Least developed countries in 1993 to that in 1998?
Keep it short and to the point. 1.78. What is the ratio of the Electricity production(% of total) in Sweden in 1993 to that in 1998?
Provide a succinct answer. 1.02. What is the ratio of the Electricity production(% of total) of Vietnam in 1993 to that in 1998?
Your response must be concise. 0.37. What is the ratio of the Electricity production(% of total) of High income in 1993 to that in 1999?
Offer a very short reply. 1.01. What is the ratio of the Electricity production(% of total) in Least developed countries in 1993 to that in 1999?
Your answer should be compact. 1.95. What is the ratio of the Electricity production(% of total) of Sweden in 1993 to that in 1999?
Give a very brief answer. 0.94. What is the ratio of the Electricity production(% of total) of Vietnam in 1993 to that in 1999?
Your answer should be compact. 0.48. What is the ratio of the Electricity production(% of total) in High income in 1993 to that in 2000?
Offer a very short reply. 0.99. What is the ratio of the Electricity production(% of total) of Least developed countries in 1993 to that in 2000?
Provide a short and direct response. 1.85. What is the ratio of the Electricity production(% of total) in Sweden in 1993 to that in 2000?
Provide a succinct answer. 1.13. What is the ratio of the Electricity production(% of total) of Vietnam in 1993 to that in 2000?
Your response must be concise. 0.51. What is the ratio of the Electricity production(% of total) of High income in 1994 to that in 1995?
Keep it short and to the point. 1.01. What is the ratio of the Electricity production(% of total) in Least developed countries in 1994 to that in 1995?
Give a very brief answer. 1.09. What is the ratio of the Electricity production(% of total) of Sweden in 1994 to that in 1995?
Your answer should be very brief. 1.11. What is the ratio of the Electricity production(% of total) in Vietnam in 1994 to that in 1995?
Provide a short and direct response. 0.63. What is the ratio of the Electricity production(% of total) in Least developed countries in 1994 to that in 1996?
Your response must be concise. 1.15. What is the ratio of the Electricity production(% of total) of Sweden in 1994 to that in 1996?
Make the answer very short. 0.72. What is the ratio of the Electricity production(% of total) of Vietnam in 1994 to that in 1996?
Provide a succinct answer. 0.62. What is the ratio of the Electricity production(% of total) of Least developed countries in 1994 to that in 1997?
Make the answer very short. 1.54. What is the ratio of the Electricity production(% of total) in Sweden in 1994 to that in 1997?
Your answer should be compact. 1.2. What is the ratio of the Electricity production(% of total) in Vietnam in 1994 to that in 1997?
Your response must be concise. 0.5. What is the ratio of the Electricity production(% of total) of High income in 1994 to that in 1998?
Provide a short and direct response. 0.99. What is the ratio of the Electricity production(% of total) in Least developed countries in 1994 to that in 1998?
Give a very brief answer. 1.65. What is the ratio of the Electricity production(% of total) in Sweden in 1994 to that in 1998?
Your answer should be very brief. 1.17. What is the ratio of the Electricity production(% of total) in Vietnam in 1994 to that in 1998?
Offer a terse response. 0.54. What is the ratio of the Electricity production(% of total) of High income in 1994 to that in 1999?
Your answer should be compact. 1.01. What is the ratio of the Electricity production(% of total) in Least developed countries in 1994 to that in 1999?
Your answer should be compact. 1.81. What is the ratio of the Electricity production(% of total) in Sweden in 1994 to that in 1999?
Keep it short and to the point. 1.09. What is the ratio of the Electricity production(% of total) of Vietnam in 1994 to that in 1999?
Your response must be concise. 0.7. What is the ratio of the Electricity production(% of total) of High income in 1994 to that in 2000?
Keep it short and to the point. 0.99. What is the ratio of the Electricity production(% of total) in Least developed countries in 1994 to that in 2000?
Offer a terse response. 1.72. What is the ratio of the Electricity production(% of total) of Sweden in 1994 to that in 2000?
Offer a very short reply. 1.3. What is the ratio of the Electricity production(% of total) in Vietnam in 1994 to that in 2000?
Your response must be concise. 0.74. What is the ratio of the Electricity production(% of total) of High income in 1995 to that in 1996?
Your response must be concise. 0.98. What is the ratio of the Electricity production(% of total) in Least developed countries in 1995 to that in 1996?
Your answer should be compact. 1.05. What is the ratio of the Electricity production(% of total) of Sweden in 1995 to that in 1996?
Make the answer very short. 0.65. What is the ratio of the Electricity production(% of total) in Vietnam in 1995 to that in 1996?
Your response must be concise. 0.98. What is the ratio of the Electricity production(% of total) in Least developed countries in 1995 to that in 1997?
Your answer should be compact. 1.41. What is the ratio of the Electricity production(% of total) in Sweden in 1995 to that in 1997?
Offer a terse response. 1.08. What is the ratio of the Electricity production(% of total) of Vietnam in 1995 to that in 1997?
Your answer should be compact. 0.79. What is the ratio of the Electricity production(% of total) in High income in 1995 to that in 1998?
Provide a succinct answer. 0.98. What is the ratio of the Electricity production(% of total) of Least developed countries in 1995 to that in 1998?
Offer a terse response. 1.51. What is the ratio of the Electricity production(% of total) in Sweden in 1995 to that in 1998?
Make the answer very short. 1.05. What is the ratio of the Electricity production(% of total) in Vietnam in 1995 to that in 1998?
Provide a succinct answer. 0.86. What is the ratio of the Electricity production(% of total) in High income in 1995 to that in 1999?
Ensure brevity in your answer.  1. What is the ratio of the Electricity production(% of total) of Least developed countries in 1995 to that in 1999?
Offer a very short reply. 1.65. What is the ratio of the Electricity production(% of total) in Sweden in 1995 to that in 1999?
Your answer should be very brief. 0.98. What is the ratio of the Electricity production(% of total) of Vietnam in 1995 to that in 1999?
Keep it short and to the point. 1.12. What is the ratio of the Electricity production(% of total) in Least developed countries in 1995 to that in 2000?
Ensure brevity in your answer.  1.57. What is the ratio of the Electricity production(% of total) in Sweden in 1995 to that in 2000?
Ensure brevity in your answer.  1.17. What is the ratio of the Electricity production(% of total) in Vietnam in 1995 to that in 2000?
Offer a very short reply. 1.17. What is the ratio of the Electricity production(% of total) of Least developed countries in 1996 to that in 1997?
Give a very brief answer. 1.34. What is the ratio of the Electricity production(% of total) of Sweden in 1996 to that in 1997?
Provide a short and direct response. 1.67. What is the ratio of the Electricity production(% of total) of Vietnam in 1996 to that in 1997?
Provide a short and direct response. 0.81. What is the ratio of the Electricity production(% of total) in Least developed countries in 1996 to that in 1998?
Provide a short and direct response. 1.44. What is the ratio of the Electricity production(% of total) in Sweden in 1996 to that in 1998?
Provide a short and direct response. 1.63. What is the ratio of the Electricity production(% of total) of Vietnam in 1996 to that in 1998?
Your response must be concise. 0.87. What is the ratio of the Electricity production(% of total) in High income in 1996 to that in 1999?
Offer a very short reply. 1.02. What is the ratio of the Electricity production(% of total) in Least developed countries in 1996 to that in 1999?
Give a very brief answer. 1.57. What is the ratio of the Electricity production(% of total) of Sweden in 1996 to that in 1999?
Your answer should be very brief. 1.51. What is the ratio of the Electricity production(% of total) in Vietnam in 1996 to that in 1999?
Your answer should be very brief. 1.13. What is the ratio of the Electricity production(% of total) of Least developed countries in 1996 to that in 2000?
Your answer should be very brief. 1.49. What is the ratio of the Electricity production(% of total) in Sweden in 1996 to that in 2000?
Make the answer very short. 1.81. What is the ratio of the Electricity production(% of total) in Vietnam in 1996 to that in 2000?
Offer a very short reply. 1.19. What is the ratio of the Electricity production(% of total) of Least developed countries in 1997 to that in 1998?
Provide a succinct answer. 1.07. What is the ratio of the Electricity production(% of total) in Vietnam in 1997 to that in 1998?
Offer a very short reply. 1.08. What is the ratio of the Electricity production(% of total) of High income in 1997 to that in 1999?
Your answer should be very brief. 1.02. What is the ratio of the Electricity production(% of total) of Least developed countries in 1997 to that in 1999?
Give a very brief answer. 1.17. What is the ratio of the Electricity production(% of total) of Sweden in 1997 to that in 1999?
Your response must be concise. 0.91. What is the ratio of the Electricity production(% of total) in Vietnam in 1997 to that in 1999?
Ensure brevity in your answer.  1.4. What is the ratio of the Electricity production(% of total) in Least developed countries in 1997 to that in 2000?
Give a very brief answer. 1.11. What is the ratio of the Electricity production(% of total) of Sweden in 1997 to that in 2000?
Provide a succinct answer. 1.08. What is the ratio of the Electricity production(% of total) of Vietnam in 1997 to that in 2000?
Your answer should be compact. 1.47. What is the ratio of the Electricity production(% of total) in High income in 1998 to that in 1999?
Your answer should be compact. 1.02. What is the ratio of the Electricity production(% of total) in Least developed countries in 1998 to that in 1999?
Your answer should be very brief. 1.09. What is the ratio of the Electricity production(% of total) in Sweden in 1998 to that in 1999?
Provide a short and direct response. 0.93. What is the ratio of the Electricity production(% of total) of Vietnam in 1998 to that in 1999?
Keep it short and to the point. 1.3. What is the ratio of the Electricity production(% of total) in High income in 1998 to that in 2000?
Keep it short and to the point. 0.99. What is the ratio of the Electricity production(% of total) of Least developed countries in 1998 to that in 2000?
Offer a very short reply. 1.04. What is the ratio of the Electricity production(% of total) in Sweden in 1998 to that in 2000?
Offer a terse response. 1.11. What is the ratio of the Electricity production(% of total) of Vietnam in 1998 to that in 2000?
Your answer should be compact. 1.36. What is the ratio of the Electricity production(% of total) in High income in 1999 to that in 2000?
Your answer should be compact. 0.98. What is the ratio of the Electricity production(% of total) of Least developed countries in 1999 to that in 2000?
Your response must be concise. 0.95. What is the ratio of the Electricity production(% of total) in Sweden in 1999 to that in 2000?
Your answer should be compact. 1.19. What is the ratio of the Electricity production(% of total) of Vietnam in 1999 to that in 2000?
Keep it short and to the point. 1.05. What is the difference between the highest and the second highest Electricity production(% of total) in High income?
Your answer should be very brief. 0.26. What is the difference between the highest and the second highest Electricity production(% of total) of Least developed countries?
Give a very brief answer. 0.01. What is the difference between the highest and the second highest Electricity production(% of total) in Sweden?
Your answer should be very brief. 0.86. What is the difference between the highest and the second highest Electricity production(% of total) in Vietnam?
Ensure brevity in your answer.  1.33. What is the difference between the highest and the lowest Electricity production(% of total) in High income?
Give a very brief answer. 0.89. What is the difference between the highest and the lowest Electricity production(% of total) in Least developed countries?
Provide a short and direct response. 0.09. What is the difference between the highest and the lowest Electricity production(% of total) in Sweden?
Offer a very short reply. 1.37. What is the difference between the highest and the lowest Electricity production(% of total) in Vietnam?
Keep it short and to the point. 11.4. 